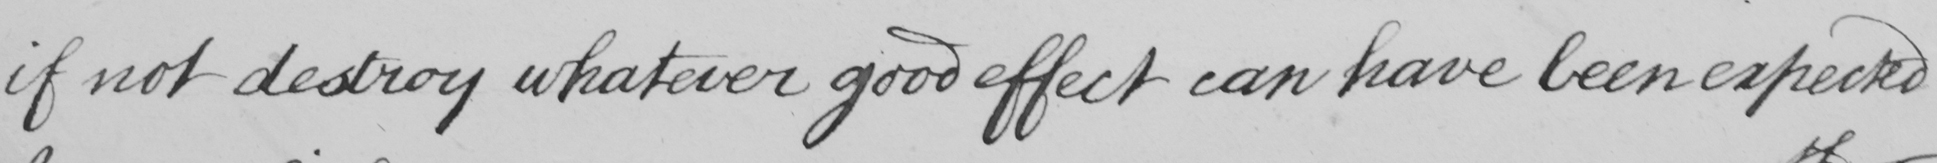What text is written in this handwritten line? if not destroy whatever good effect can have been expected 